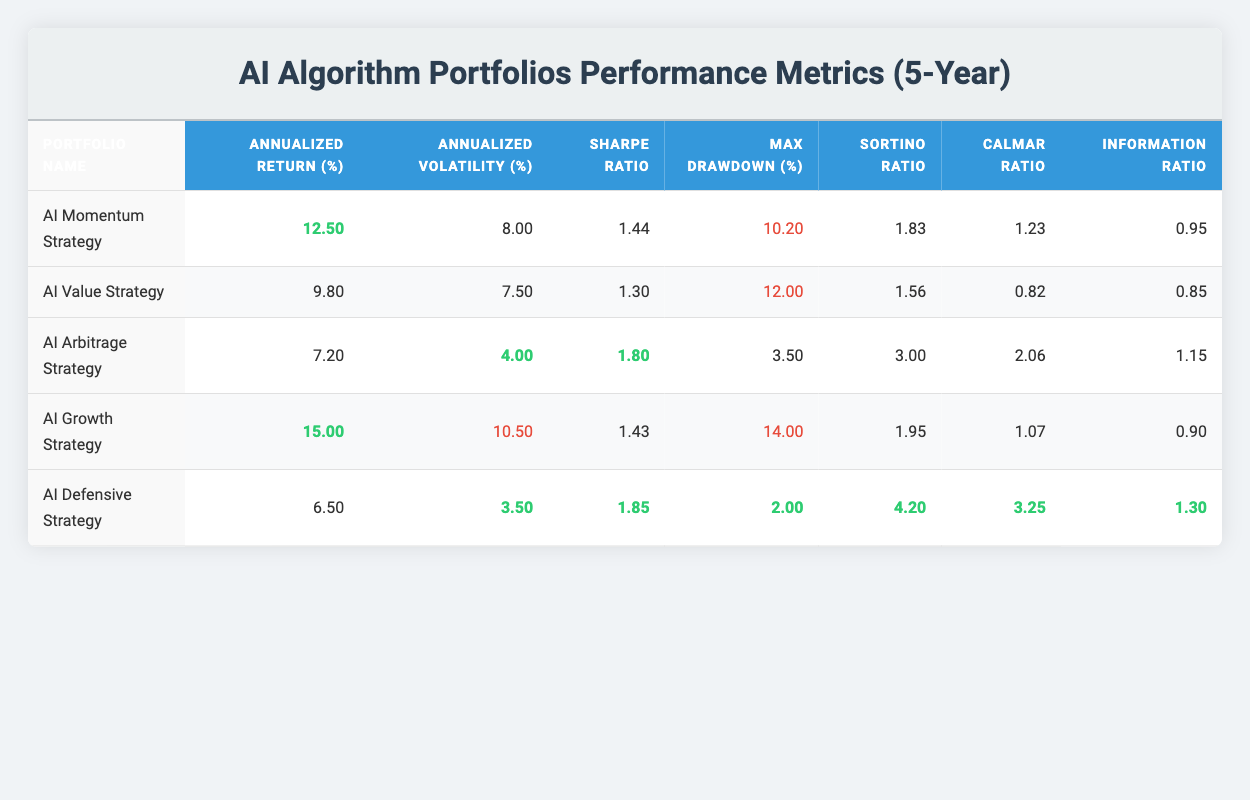What is the annualized return of the AI Momentum Strategy? The annualized return of the AI Momentum Strategy can be found in the table under the column "Annualized Return (%)". It states that the return is 12.5%.
Answer: 12.5% Which portfolio has the highest Sharpe Ratio? In the table, the "Sharpe Ratio" for each portfolio is listed. By comparing the values, the AI Arbitrage Strategy has the highest Sharpe Ratio at 1.80.
Answer: AI Arbitrage Strategy What is the average Annualized Volatility of the AI portfolios? The annualized volatility for each portfolio is 8.00, 7.50, 4.00, 10.50, and 3.50. To find the average, sum these values (8.00 + 7.50 + 4.00 + 10.50 + 3.50) = 33.50 and divide by the number of portfolios (5), yielding 33.50/5 = 6.70.
Answer: 6.70 Is the Sortino Ratio of the AI Defensive Strategy higher than that of the AI Value Strategy? The Sortino Ratio for AI Defensive Strategy is 4.20, and for AI Value Strategy, it is 1.56. Since 4.20 is greater than 1.56, the statement is true.
Answer: Yes What is the difference between the maximum drawdown of the AI Growth Strategy and the AI Defensive Strategy? The maximum drawdown for the AI Growth Strategy is 14.0% and for AI Defensive Strategy it is 2.0%. The difference is calculated as 14.0 - 2.0 = 12.0.
Answer: 12.0 